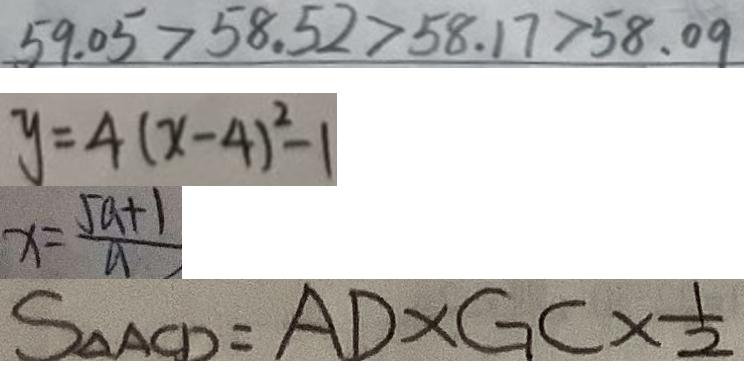Convert formula to latex. <formula><loc_0><loc_0><loc_500><loc_500>5 9 . 0 5 > 5 8 . 5 2 > 5 8 . 1 7 > 5 8 . 0 9 
 y = 4 ( x - 4 ) ^ { 2 } - 1 
 x = \frac { 5 a + 1 } { a } 
 S _ { \Delta A C D } = A D \times G C \times \frac { 1 } { 2 }</formula> 